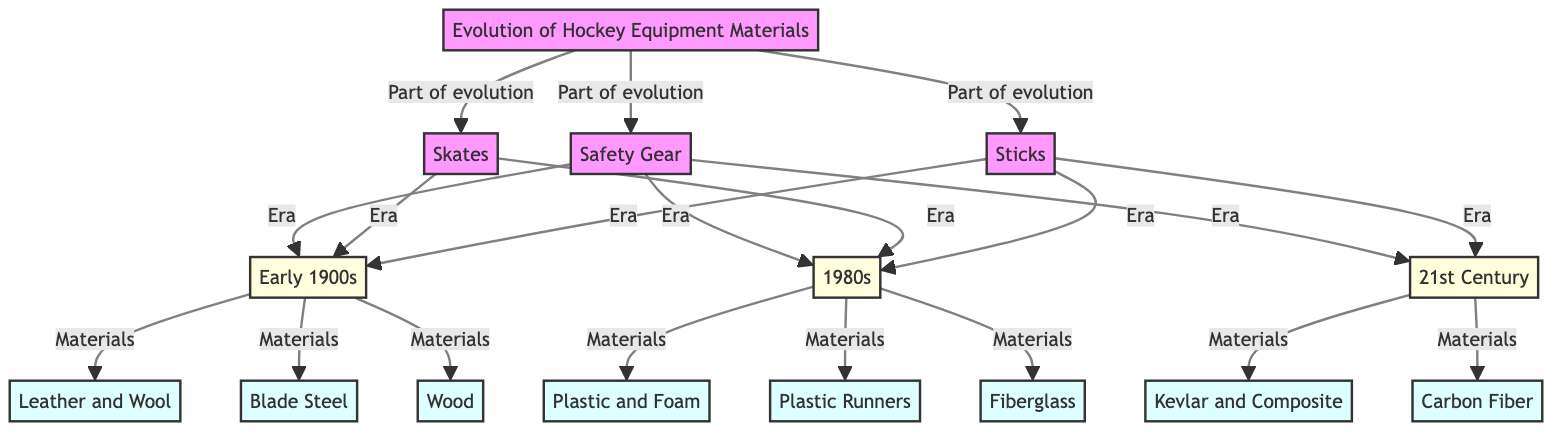What materials were used in safety gear during the early 1900s? The flowchart indicates that the materials used for safety gear in the early 1900s were leather and wool, which can be found under the 'Safety Gear' section connected to the 'Early 1900s' node.
Answer: Leather and Wool How many eras are identified in the evolution of skates? The diagram outlines three distinct eras for skates: Early 1900s, 1980s, and 21st Century. Each era leads to a different material noted under the 'Skates' section.
Answer: 3 What material is associated with skates from the 1980s? The diagram specifies that in the 1980s, the material used for skates was plastic runners. This information can be located under the 'Skates' section connected to the '1980s' node.
Answer: Plastic Runners What are the materials used for sticks in the 21st Century? According to the diagram, sticks in the 21st Century use carbon fiber as the material. This is linked through the 'Sticks' section and its connection to the '21st Century' node.
Answer: Carbon Fiber Which material replaced wood in the evolution of sticks? The flowchart shows that fiberglass came after wood as the material for sticks, specifically noted under the 1980s era, following the transition from wood used in the early 1900s.
Answer: Fiberglass What materials were used for safety gear in the 21st Century? The diagram indicates that in the 21st Century, safety gear is made from Kevlar and composite materials, which are found in the corresponding section for safety gear with the label '21st Century'.
Answer: Kevlar and Composite What is the relationship between sticks and skates in terms of eras? The diagram shows that both sticks and skates share the same eras: Early 1900s, 1980s, and 21st Century, indicating that both types of equipment evolved over the same timeline.
Answer: Shared Eras How many materials are listed for each category of hockey equipment? The diagram displays four materials listed for safety gear, four for skates, and three for sticks, hence there are varying numbers depending on the type of equipment.
Answer: Varies by Category 